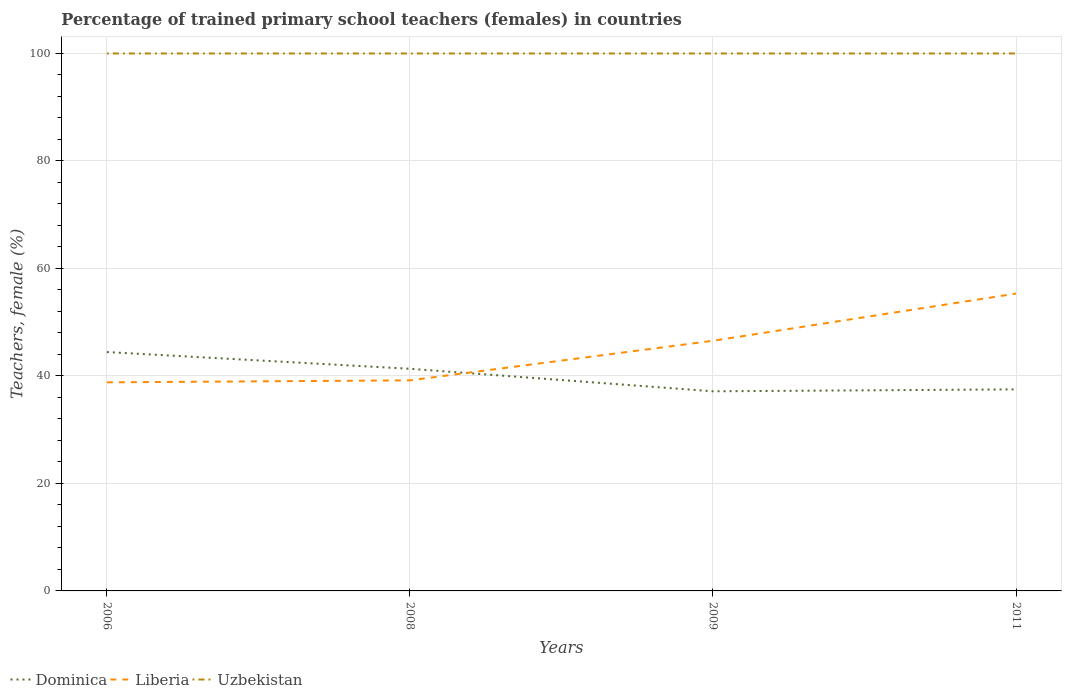Across all years, what is the maximum percentage of trained primary school teachers (females) in Dominica?
Give a very brief answer. 37.14. What is the total percentage of trained primary school teachers (females) in Dominica in the graph?
Ensure brevity in your answer.  4.19. What is the difference between the highest and the lowest percentage of trained primary school teachers (females) in Uzbekistan?
Your answer should be compact. 0. Is the percentage of trained primary school teachers (females) in Uzbekistan strictly greater than the percentage of trained primary school teachers (females) in Liberia over the years?
Provide a short and direct response. No. What is the difference between two consecutive major ticks on the Y-axis?
Your answer should be very brief. 20. Are the values on the major ticks of Y-axis written in scientific E-notation?
Your response must be concise. No. Does the graph contain any zero values?
Offer a terse response. No. Does the graph contain grids?
Your response must be concise. Yes. What is the title of the graph?
Your answer should be very brief. Percentage of trained primary school teachers (females) in countries. Does "Algeria" appear as one of the legend labels in the graph?
Offer a terse response. No. What is the label or title of the Y-axis?
Your answer should be very brief. Teachers, female (%). What is the Teachers, female (%) of Dominica in 2006?
Offer a terse response. 44.44. What is the Teachers, female (%) of Liberia in 2006?
Your answer should be compact. 38.81. What is the Teachers, female (%) in Uzbekistan in 2006?
Your answer should be compact. 100. What is the Teachers, female (%) of Dominica in 2008?
Provide a short and direct response. 41.33. What is the Teachers, female (%) of Liberia in 2008?
Provide a succinct answer. 39.18. What is the Teachers, female (%) in Dominica in 2009?
Provide a succinct answer. 37.14. What is the Teachers, female (%) in Liberia in 2009?
Provide a succinct answer. 46.54. What is the Teachers, female (%) in Dominica in 2011?
Ensure brevity in your answer.  37.5. What is the Teachers, female (%) in Liberia in 2011?
Keep it short and to the point. 55.32. What is the Teachers, female (%) of Uzbekistan in 2011?
Provide a succinct answer. 100. Across all years, what is the maximum Teachers, female (%) in Dominica?
Your answer should be compact. 44.44. Across all years, what is the maximum Teachers, female (%) of Liberia?
Provide a succinct answer. 55.32. Across all years, what is the maximum Teachers, female (%) in Uzbekistan?
Provide a short and direct response. 100. Across all years, what is the minimum Teachers, female (%) of Dominica?
Ensure brevity in your answer.  37.14. Across all years, what is the minimum Teachers, female (%) of Liberia?
Your answer should be compact. 38.81. Across all years, what is the minimum Teachers, female (%) in Uzbekistan?
Your answer should be very brief. 100. What is the total Teachers, female (%) in Dominica in the graph?
Give a very brief answer. 160.42. What is the total Teachers, female (%) in Liberia in the graph?
Give a very brief answer. 179.86. What is the difference between the Teachers, female (%) of Dominica in 2006 and that in 2008?
Give a very brief answer. 3.11. What is the difference between the Teachers, female (%) of Liberia in 2006 and that in 2008?
Your answer should be very brief. -0.37. What is the difference between the Teachers, female (%) in Dominica in 2006 and that in 2009?
Ensure brevity in your answer.  7.3. What is the difference between the Teachers, female (%) in Liberia in 2006 and that in 2009?
Ensure brevity in your answer.  -7.73. What is the difference between the Teachers, female (%) of Uzbekistan in 2006 and that in 2009?
Ensure brevity in your answer.  0. What is the difference between the Teachers, female (%) in Dominica in 2006 and that in 2011?
Your response must be concise. 6.94. What is the difference between the Teachers, female (%) of Liberia in 2006 and that in 2011?
Make the answer very short. -16.51. What is the difference between the Teachers, female (%) of Uzbekistan in 2006 and that in 2011?
Your answer should be very brief. 0. What is the difference between the Teachers, female (%) of Dominica in 2008 and that in 2009?
Keep it short and to the point. 4.19. What is the difference between the Teachers, female (%) in Liberia in 2008 and that in 2009?
Make the answer very short. -7.37. What is the difference between the Teachers, female (%) of Uzbekistan in 2008 and that in 2009?
Keep it short and to the point. 0. What is the difference between the Teachers, female (%) in Dominica in 2008 and that in 2011?
Give a very brief answer. 3.83. What is the difference between the Teachers, female (%) of Liberia in 2008 and that in 2011?
Offer a very short reply. -16.14. What is the difference between the Teachers, female (%) of Uzbekistan in 2008 and that in 2011?
Make the answer very short. 0. What is the difference between the Teachers, female (%) in Dominica in 2009 and that in 2011?
Your response must be concise. -0.36. What is the difference between the Teachers, female (%) in Liberia in 2009 and that in 2011?
Provide a succinct answer. -8.78. What is the difference between the Teachers, female (%) in Dominica in 2006 and the Teachers, female (%) in Liberia in 2008?
Offer a very short reply. 5.27. What is the difference between the Teachers, female (%) of Dominica in 2006 and the Teachers, female (%) of Uzbekistan in 2008?
Ensure brevity in your answer.  -55.56. What is the difference between the Teachers, female (%) of Liberia in 2006 and the Teachers, female (%) of Uzbekistan in 2008?
Keep it short and to the point. -61.19. What is the difference between the Teachers, female (%) in Dominica in 2006 and the Teachers, female (%) in Liberia in 2009?
Keep it short and to the point. -2.1. What is the difference between the Teachers, female (%) in Dominica in 2006 and the Teachers, female (%) in Uzbekistan in 2009?
Your answer should be compact. -55.56. What is the difference between the Teachers, female (%) in Liberia in 2006 and the Teachers, female (%) in Uzbekistan in 2009?
Provide a succinct answer. -61.19. What is the difference between the Teachers, female (%) of Dominica in 2006 and the Teachers, female (%) of Liberia in 2011?
Make the answer very short. -10.88. What is the difference between the Teachers, female (%) of Dominica in 2006 and the Teachers, female (%) of Uzbekistan in 2011?
Your response must be concise. -55.56. What is the difference between the Teachers, female (%) in Liberia in 2006 and the Teachers, female (%) in Uzbekistan in 2011?
Your answer should be very brief. -61.19. What is the difference between the Teachers, female (%) of Dominica in 2008 and the Teachers, female (%) of Liberia in 2009?
Your response must be concise. -5.21. What is the difference between the Teachers, female (%) of Dominica in 2008 and the Teachers, female (%) of Uzbekistan in 2009?
Give a very brief answer. -58.67. What is the difference between the Teachers, female (%) in Liberia in 2008 and the Teachers, female (%) in Uzbekistan in 2009?
Make the answer very short. -60.82. What is the difference between the Teachers, female (%) of Dominica in 2008 and the Teachers, female (%) of Liberia in 2011?
Offer a very short reply. -13.99. What is the difference between the Teachers, female (%) in Dominica in 2008 and the Teachers, female (%) in Uzbekistan in 2011?
Ensure brevity in your answer.  -58.67. What is the difference between the Teachers, female (%) in Liberia in 2008 and the Teachers, female (%) in Uzbekistan in 2011?
Offer a terse response. -60.82. What is the difference between the Teachers, female (%) of Dominica in 2009 and the Teachers, female (%) of Liberia in 2011?
Your answer should be compact. -18.18. What is the difference between the Teachers, female (%) in Dominica in 2009 and the Teachers, female (%) in Uzbekistan in 2011?
Offer a very short reply. -62.86. What is the difference between the Teachers, female (%) in Liberia in 2009 and the Teachers, female (%) in Uzbekistan in 2011?
Provide a succinct answer. -53.46. What is the average Teachers, female (%) in Dominica per year?
Your answer should be very brief. 40.11. What is the average Teachers, female (%) of Liberia per year?
Give a very brief answer. 44.96. In the year 2006, what is the difference between the Teachers, female (%) of Dominica and Teachers, female (%) of Liberia?
Your answer should be very brief. 5.63. In the year 2006, what is the difference between the Teachers, female (%) in Dominica and Teachers, female (%) in Uzbekistan?
Ensure brevity in your answer.  -55.56. In the year 2006, what is the difference between the Teachers, female (%) in Liberia and Teachers, female (%) in Uzbekistan?
Give a very brief answer. -61.19. In the year 2008, what is the difference between the Teachers, female (%) in Dominica and Teachers, female (%) in Liberia?
Provide a short and direct response. 2.15. In the year 2008, what is the difference between the Teachers, female (%) of Dominica and Teachers, female (%) of Uzbekistan?
Give a very brief answer. -58.67. In the year 2008, what is the difference between the Teachers, female (%) in Liberia and Teachers, female (%) in Uzbekistan?
Your answer should be very brief. -60.82. In the year 2009, what is the difference between the Teachers, female (%) of Dominica and Teachers, female (%) of Liberia?
Make the answer very short. -9.4. In the year 2009, what is the difference between the Teachers, female (%) in Dominica and Teachers, female (%) in Uzbekistan?
Provide a short and direct response. -62.86. In the year 2009, what is the difference between the Teachers, female (%) of Liberia and Teachers, female (%) of Uzbekistan?
Keep it short and to the point. -53.46. In the year 2011, what is the difference between the Teachers, female (%) of Dominica and Teachers, female (%) of Liberia?
Provide a succinct answer. -17.82. In the year 2011, what is the difference between the Teachers, female (%) of Dominica and Teachers, female (%) of Uzbekistan?
Keep it short and to the point. -62.5. In the year 2011, what is the difference between the Teachers, female (%) in Liberia and Teachers, female (%) in Uzbekistan?
Provide a succinct answer. -44.68. What is the ratio of the Teachers, female (%) of Dominica in 2006 to that in 2008?
Ensure brevity in your answer.  1.08. What is the ratio of the Teachers, female (%) in Liberia in 2006 to that in 2008?
Provide a short and direct response. 0.99. What is the ratio of the Teachers, female (%) of Uzbekistan in 2006 to that in 2008?
Ensure brevity in your answer.  1. What is the ratio of the Teachers, female (%) in Dominica in 2006 to that in 2009?
Provide a short and direct response. 1.2. What is the ratio of the Teachers, female (%) of Liberia in 2006 to that in 2009?
Offer a very short reply. 0.83. What is the ratio of the Teachers, female (%) of Dominica in 2006 to that in 2011?
Ensure brevity in your answer.  1.19. What is the ratio of the Teachers, female (%) of Liberia in 2006 to that in 2011?
Ensure brevity in your answer.  0.7. What is the ratio of the Teachers, female (%) in Dominica in 2008 to that in 2009?
Offer a very short reply. 1.11. What is the ratio of the Teachers, female (%) of Liberia in 2008 to that in 2009?
Ensure brevity in your answer.  0.84. What is the ratio of the Teachers, female (%) of Uzbekistan in 2008 to that in 2009?
Ensure brevity in your answer.  1. What is the ratio of the Teachers, female (%) in Dominica in 2008 to that in 2011?
Make the answer very short. 1.1. What is the ratio of the Teachers, female (%) of Liberia in 2008 to that in 2011?
Offer a terse response. 0.71. What is the ratio of the Teachers, female (%) in Uzbekistan in 2008 to that in 2011?
Provide a succinct answer. 1. What is the ratio of the Teachers, female (%) of Dominica in 2009 to that in 2011?
Keep it short and to the point. 0.99. What is the ratio of the Teachers, female (%) in Liberia in 2009 to that in 2011?
Offer a terse response. 0.84. What is the difference between the highest and the second highest Teachers, female (%) in Dominica?
Provide a succinct answer. 3.11. What is the difference between the highest and the second highest Teachers, female (%) of Liberia?
Make the answer very short. 8.78. What is the difference between the highest and the lowest Teachers, female (%) in Dominica?
Offer a very short reply. 7.3. What is the difference between the highest and the lowest Teachers, female (%) in Liberia?
Your response must be concise. 16.51. 